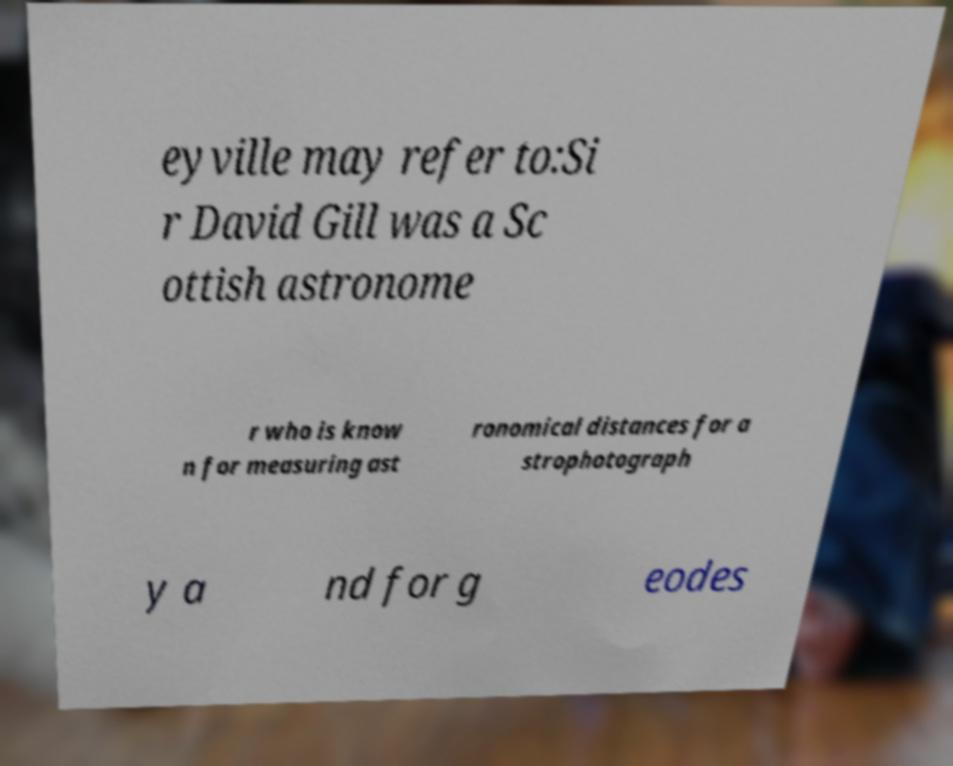I need the written content from this picture converted into text. Can you do that? eyville may refer to:Si r David Gill was a Sc ottish astronome r who is know n for measuring ast ronomical distances for a strophotograph y a nd for g eodes 